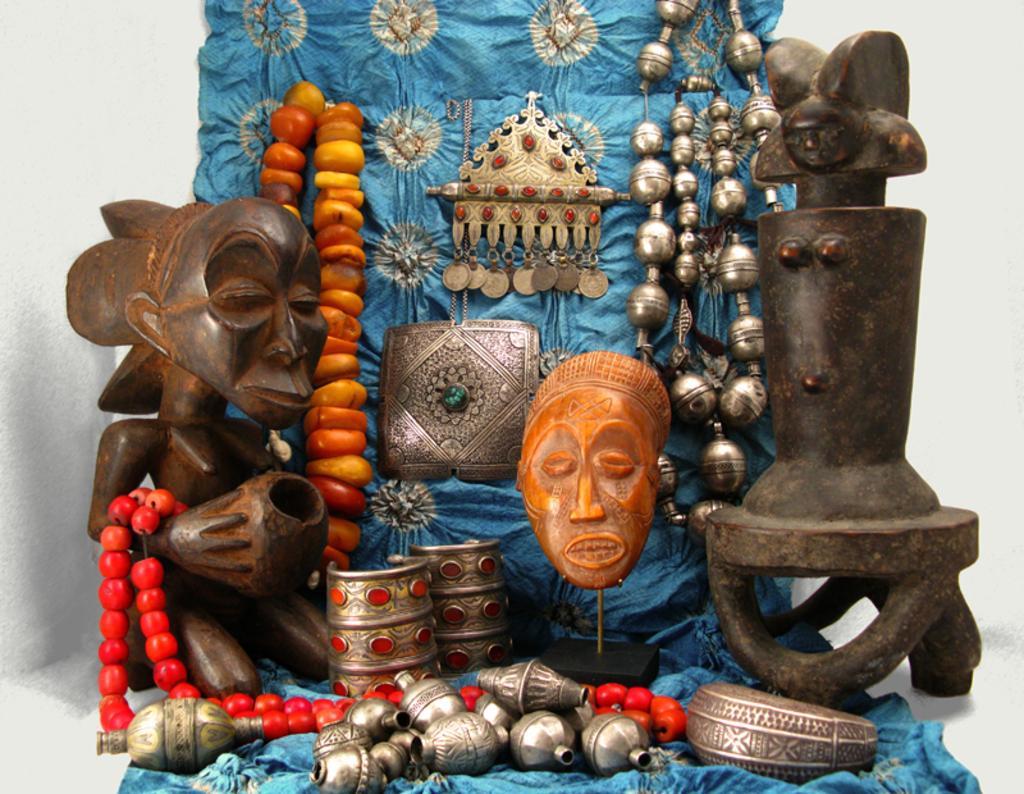Please provide a concise description of this image. In this picture, we see wooden carved things. Beside that, we see beads and chains. We even see some items which are made up of bronze metal. Behind that, we see a blue color cloth. In the background, it is white in color. 